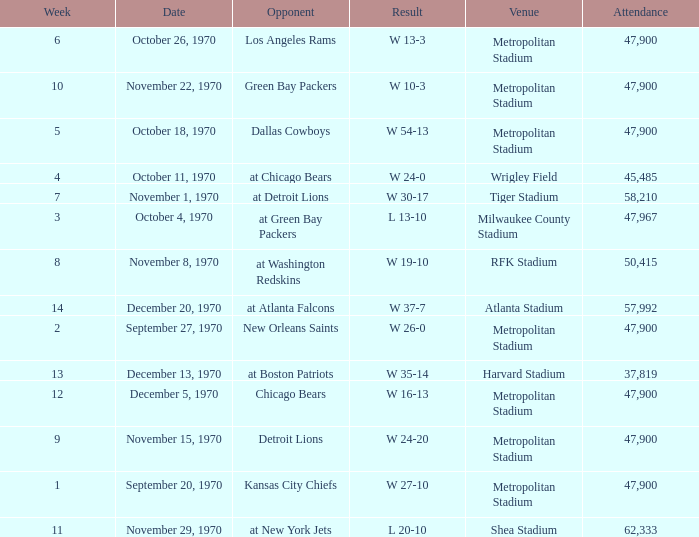How many people attended the game with a result of w 16-13 and a week earlier than 12? None. 